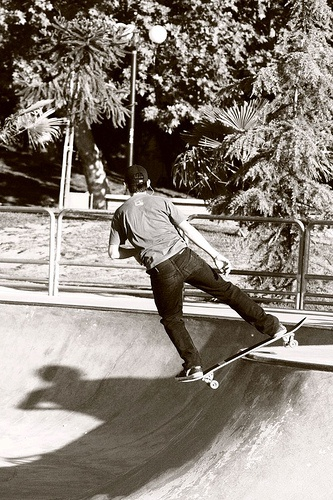Describe the objects in this image and their specific colors. I can see people in black, lightgray, darkgray, and gray tones and skateboard in black, white, gray, and darkgray tones in this image. 